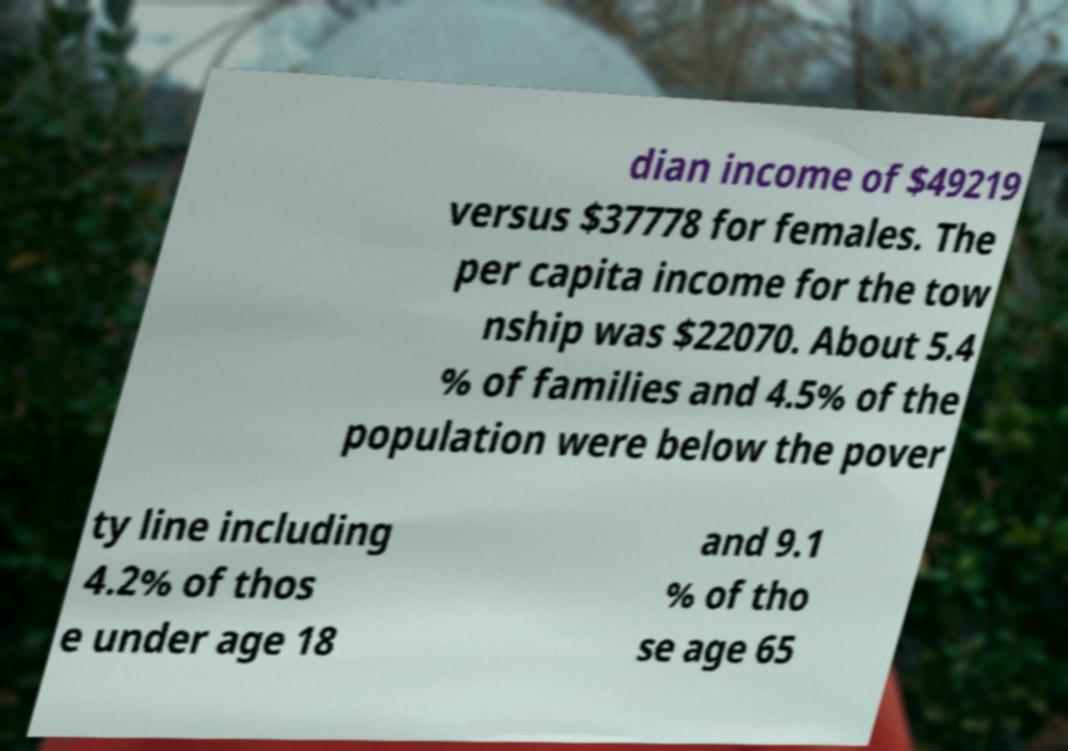Can you accurately transcribe the text from the provided image for me? dian income of $49219 versus $37778 for females. The per capita income for the tow nship was $22070. About 5.4 % of families and 4.5% of the population were below the pover ty line including 4.2% of thos e under age 18 and 9.1 % of tho se age 65 